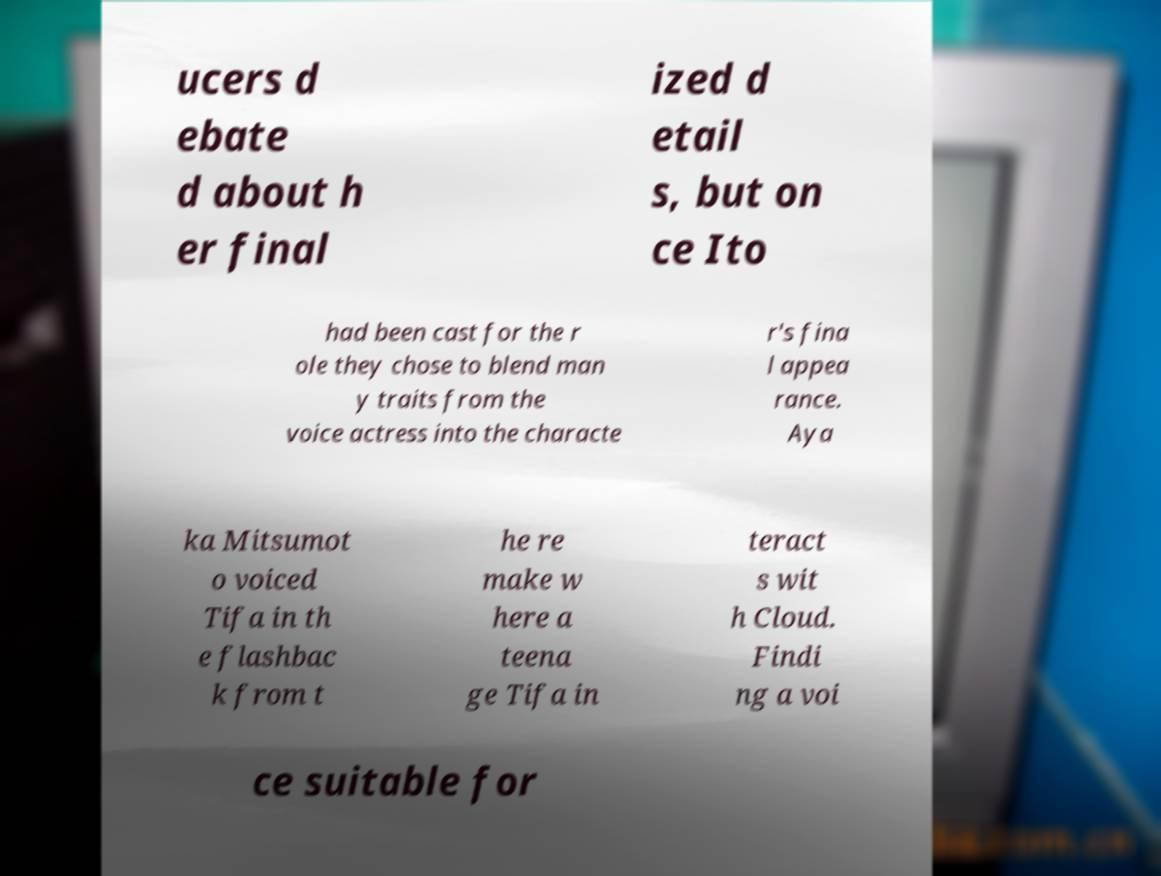There's text embedded in this image that I need extracted. Can you transcribe it verbatim? ucers d ebate d about h er final ized d etail s, but on ce Ito had been cast for the r ole they chose to blend man y traits from the voice actress into the characte r's fina l appea rance. Aya ka Mitsumot o voiced Tifa in th e flashbac k from t he re make w here a teena ge Tifa in teract s wit h Cloud. Findi ng a voi ce suitable for 